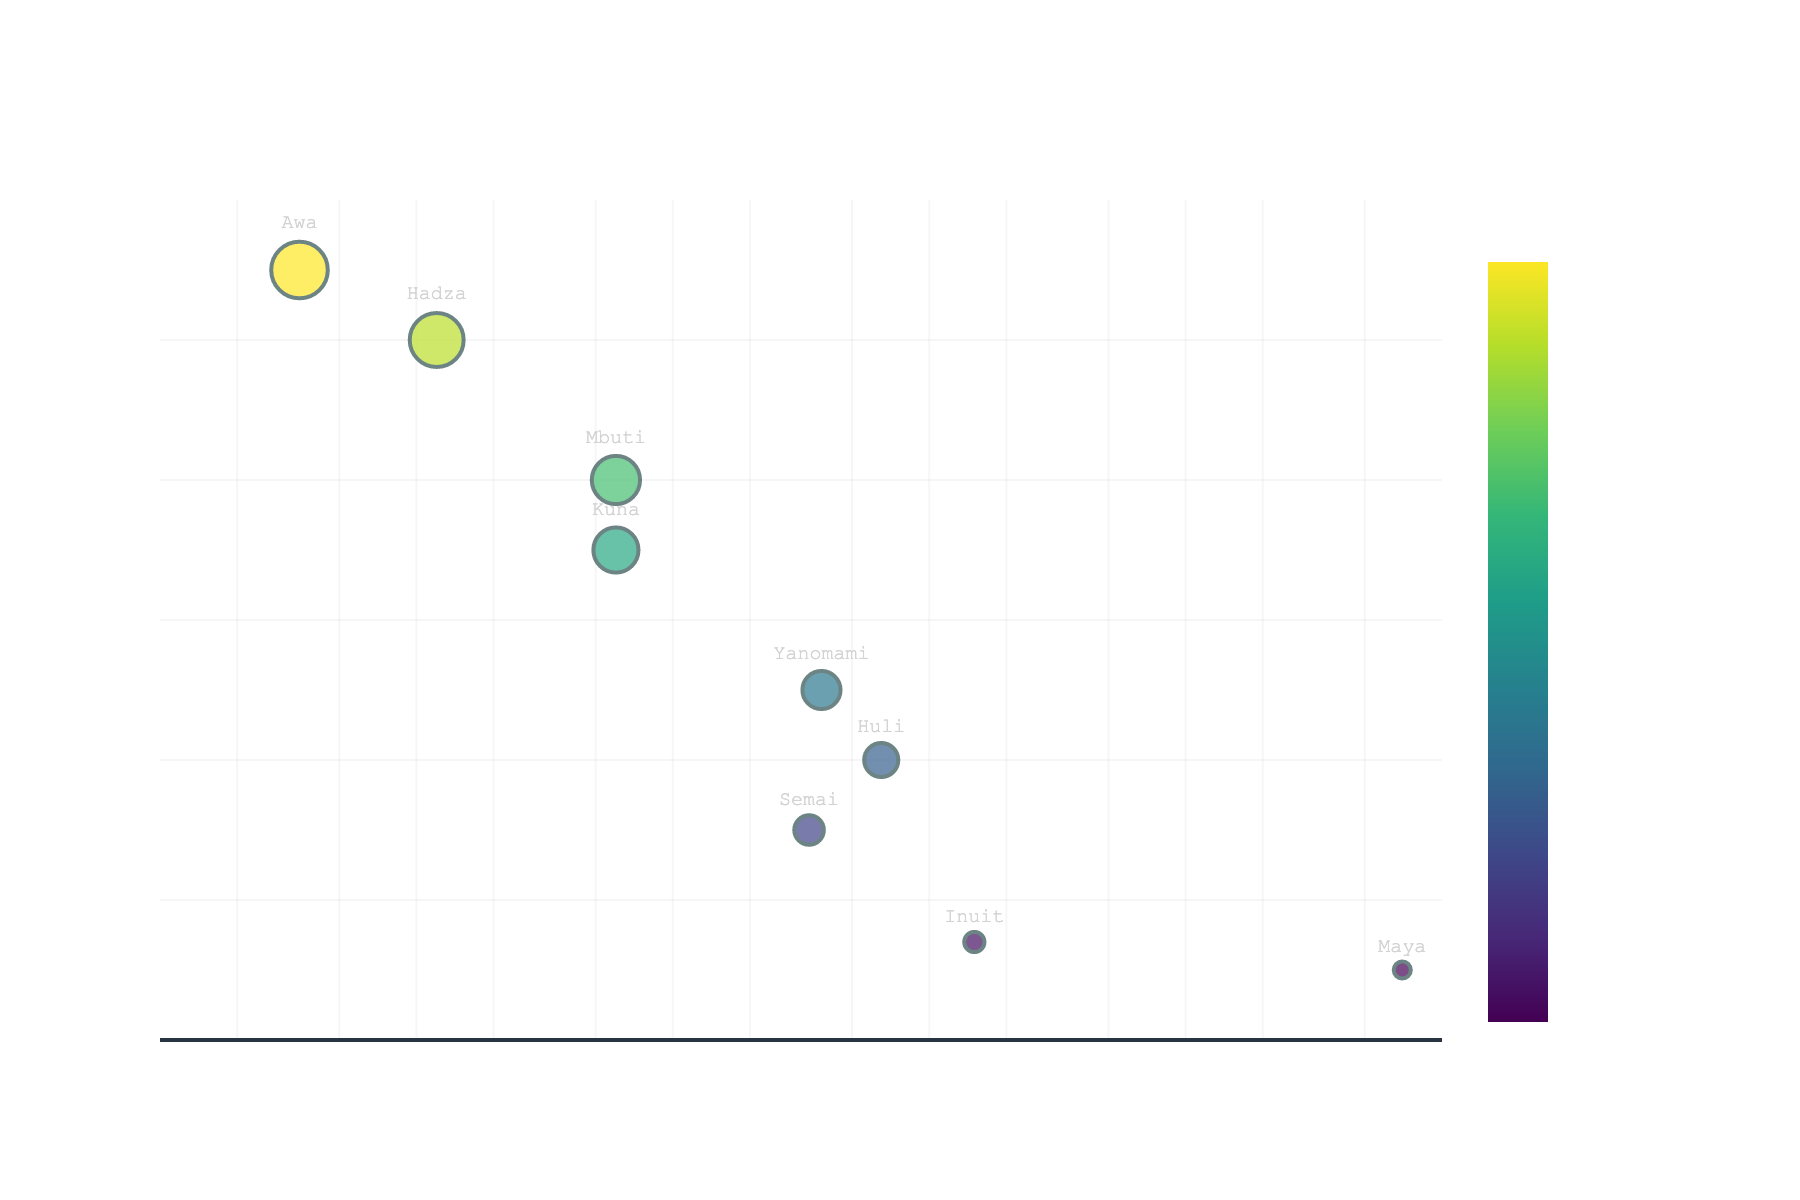How many data points are shown in the figure? There are 9 tribes listed in the dataset provided. Each of these tribes corresponds to a single data point in the scatter plot.
Answer: 9 What is the tribe with the smallest population size? The tribe with the smallest population size can be identified by finding the leftmost point on the plot (since the x-axis is on a log scale, smaller values are further to the left). The tribe "Awa" is on the far left at a population size of 350.
Answer: Awa Which tribe has the highest frequency of traditional rituals? The tribe with the highest frequency of traditional rituals can be identified by finding the highest point on the plot (highest y-value). "Awa" has the highest frequency with 55 traditional rituals.
Answer: Awa What is the relationship between population size and frequency of traditional rituals? Observing the scatter plot, it is apparent that tribes with larger populations tend to have a lower frequency of traditional rituals, and smaller tribes tend to have higher frequencies.
Answer: Inversely proportional Which tribe has the largest population size, and what is its frequency of traditional rituals? The largest population size can be identified by finding the rightmost point on the plot. The Maya tribe has the largest population size with 7,000,000, and its frequency of traditional rituals is 5.
Answer: Maya, 5 How does the frequency of traditional rituals for the Inuit tribe compare to the Huli tribe? To compare the two tribes, find their positions on the plot. The Inuit tribe has a ritual frequency of 7, while the Huli tribe has a ritual frequency of 20. This shows that the Huli tribe practices traditional rituals more frequently than the Inuit tribe.
Answer: The Huli tribe has more frequent rituals than the Inuit tribe What is the combined population size of the Yanomami and Semai tribes? The population sizes of the Yanomami and Semai tribes are 38,000 and 34,000 respectively. Adding these together: 38,000 + 34,000 = 72,000.
Answer: 72,000 Is there any tribe that does not follow the general inverse trend between population size and frequency of traditional rituals? By looking closely at the scatter plot, we can see that the Kuna and the Mbuti tribes, both having the same population size of 6000, follow the general trend with higher frequencies than their larger counterparts.
Answer: No tribe significantly deviates from the trend 